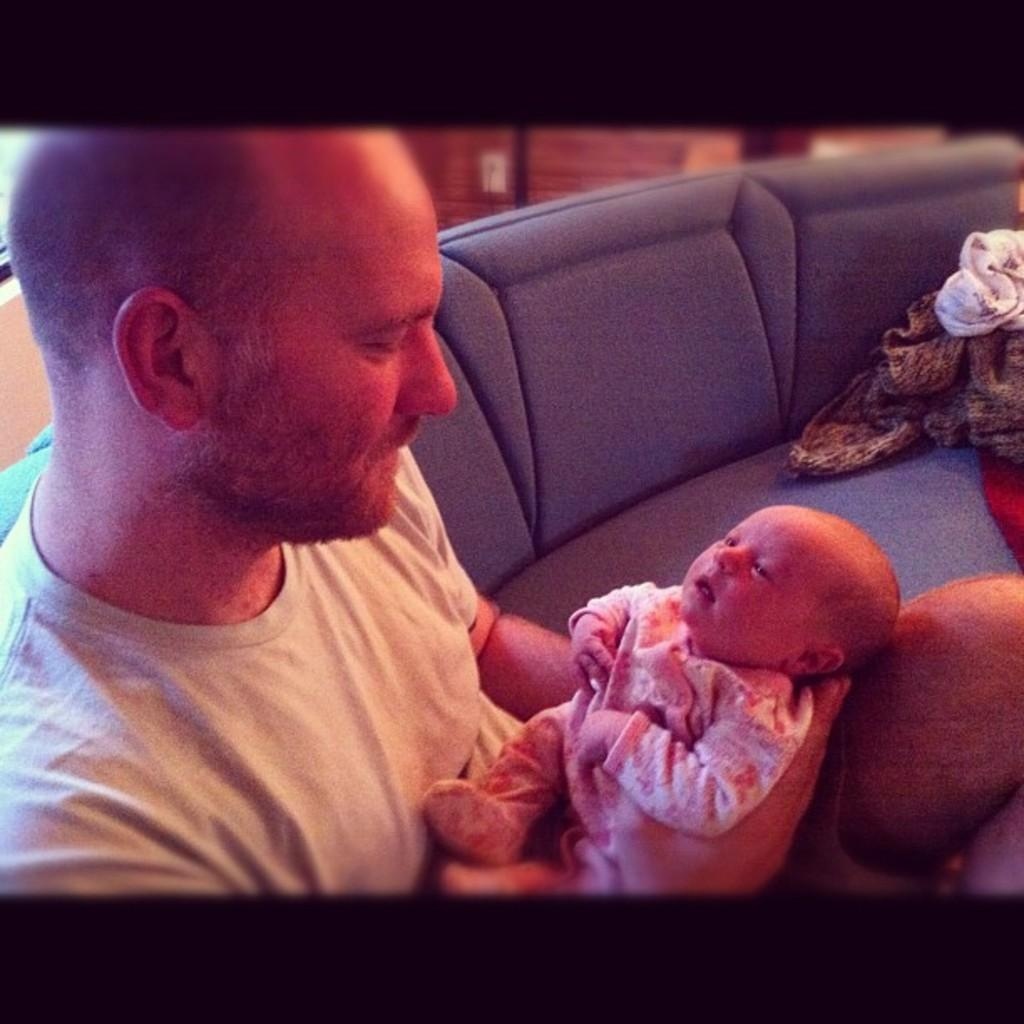Who is present in the image? There is a man and a baby in the image. What can be seen on the right side of the image? There are clothes on the sofa on the right side of the image. Where is the giraffe in the image? There is no giraffe present in the image. What type of grain is being used to feed the baby in the image? The image does not show any grain or feeding activity involving the baby. 